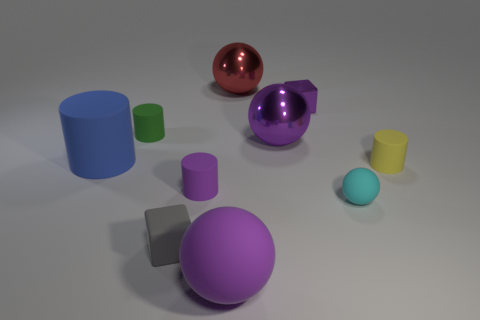Subtract 1 cylinders. How many cylinders are left? 3 Subtract all blocks. How many objects are left? 8 Subtract all small gray rubber cubes. Subtract all big red metallic balls. How many objects are left? 8 Add 1 cyan matte things. How many cyan matte things are left? 2 Add 7 cyan things. How many cyan things exist? 8 Subtract 0 brown spheres. How many objects are left? 10 